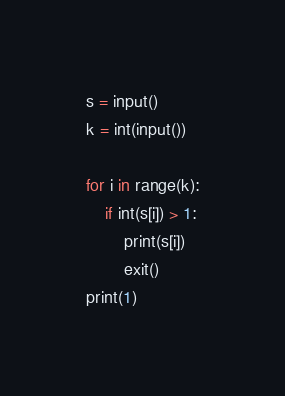<code> <loc_0><loc_0><loc_500><loc_500><_Python_>s = input()
k = int(input())

for i in range(k):
    if int(s[i]) > 1:
        print(s[i])
        exit()
print(1)
</code> 